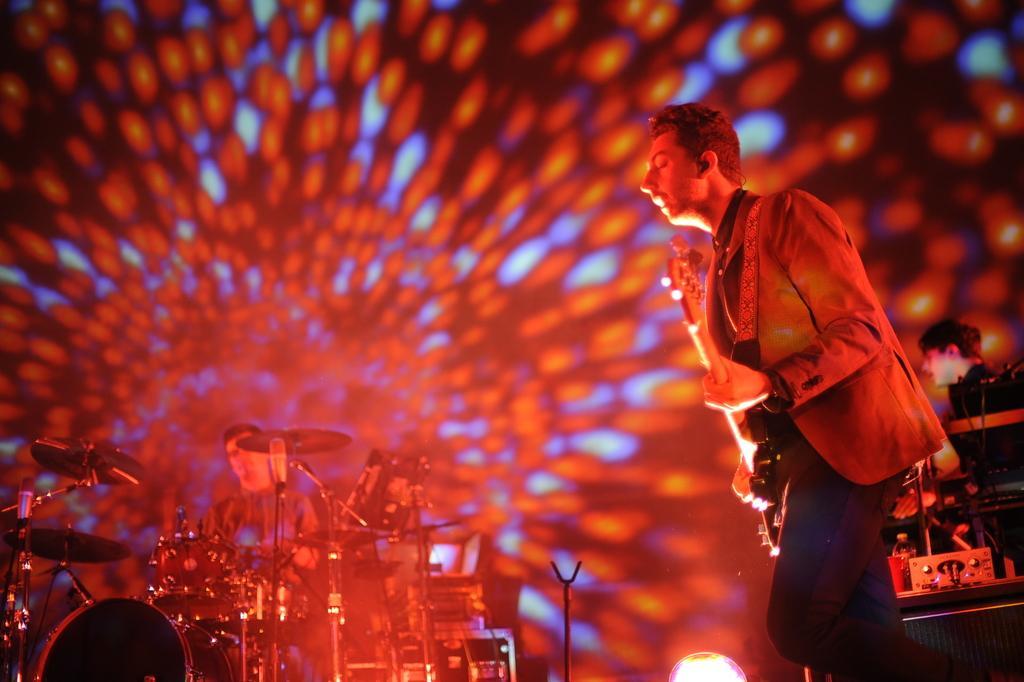Could you give a brief overview of what you see in this image? On the right side of the image we can see a man is standing and holding a guitar and also we can see the musical instruments, bottle, amplifier and a person is sitting. At the bottom of the image we can see the musical instruments, light, mic with stand and a person is sitting. In the background of the image we can see the lights. 